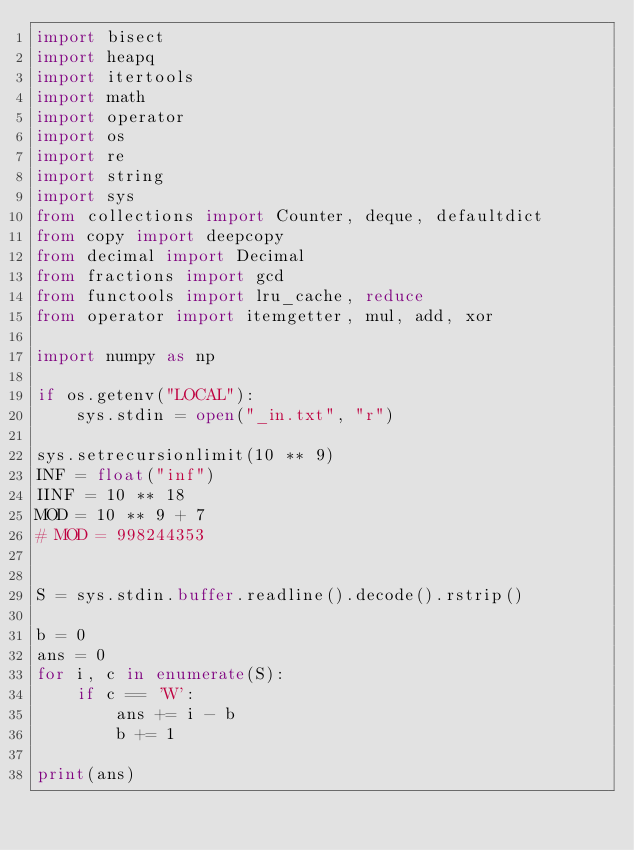<code> <loc_0><loc_0><loc_500><loc_500><_Python_>import bisect
import heapq
import itertools
import math
import operator
import os
import re
import string
import sys
from collections import Counter, deque, defaultdict
from copy import deepcopy
from decimal import Decimal
from fractions import gcd
from functools import lru_cache, reduce
from operator import itemgetter, mul, add, xor

import numpy as np

if os.getenv("LOCAL"):
    sys.stdin = open("_in.txt", "r")

sys.setrecursionlimit(10 ** 9)
INF = float("inf")
IINF = 10 ** 18
MOD = 10 ** 9 + 7
# MOD = 998244353


S = sys.stdin.buffer.readline().decode().rstrip()

b = 0
ans = 0
for i, c in enumerate(S):
    if c == 'W':
        ans += i - b
        b += 1

print(ans)
</code> 